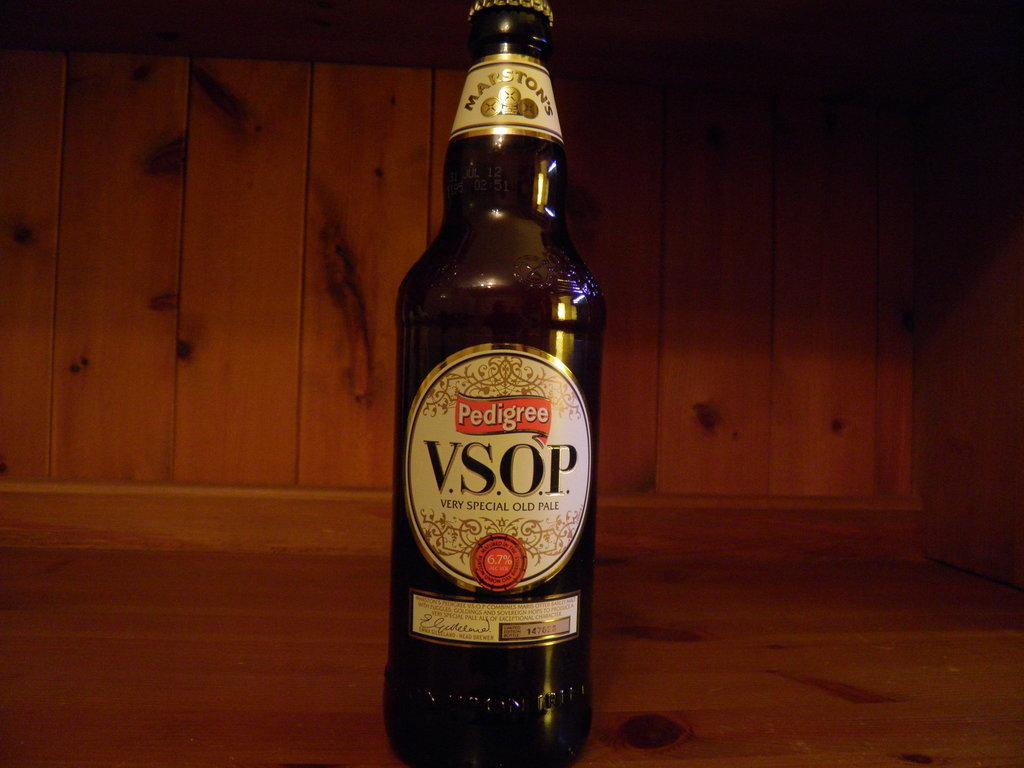<image>
Render a clear and concise summary of the photo. Bottle of Pedigree V.S.O.P Very Special OLD PALE 